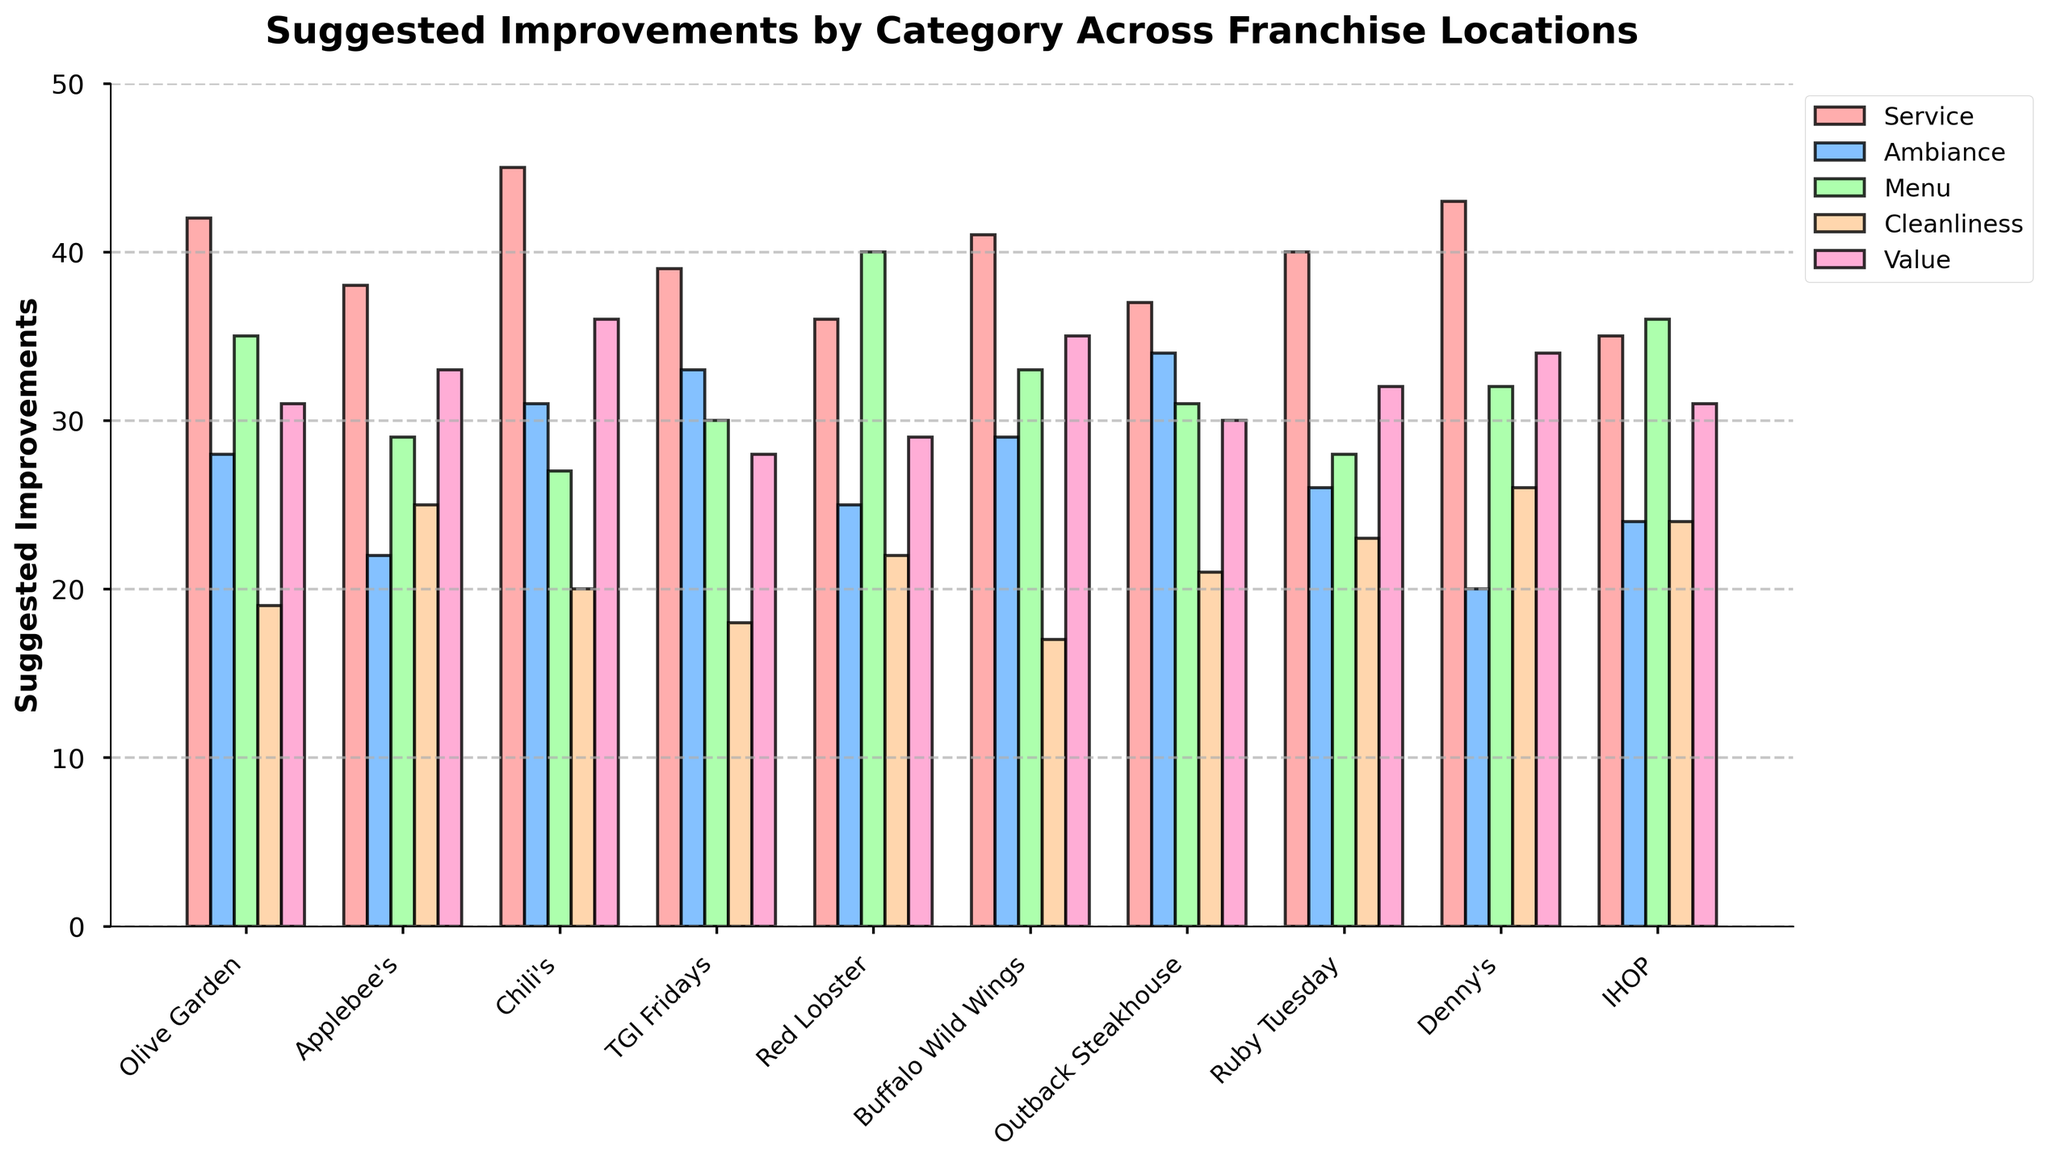What's the total number of suggested improvements for Service across all locations? Sum the suggested improvements for Service: 42 + 38 + 45 + 39 + 36 + 41 + 37 + 40 + 43 + 35 = 396.
Answer: 396 Which franchise location has the highest number of suggested improvements for Ambiance? Compare the values in the Ambiance column; the highest value is 34 for Outback Steakhouse.
Answer: Outback Steakhouse What's the average number of suggested improvements for Menu and Cleanliness across all franchise locations? Average for Menu: (35 + 29 + 27 + 30 + 40 + 33 + 31 + 28 + 32 + 36)/10 = 32.1; Average for Cleanliness: (19 + 25 + 20 + 18 + 22 + 17 + 21 + 23 + 26 + 24)/10 = 21.5. The combined average is (32.1 + 21.5)/2 = 26.8.
Answer: 26.8 Which category has the lowest suggested improvement for Denny's? Identify the lowest value in the row for Denny's: Service=43, Ambiance=20, Menu=32, Cleanliness=26, Value=34. The lowest is 20 for Ambiance.
Answer: Ambiance For which category does Olive Garden have the most suggested improvements? Identify the highest value in the row for Olive Garden: Service=42, Ambiance=28, Menu=35, Cleanliness=19, Value=31. The highest is 42 for Service.
Answer: Service How many more suggested improvements for Value did Chili's receive compared to Applebee's? Subtract the Value of Applebee's (33) from the Value of Chili's (36): 36 - 33 = 3.
Answer: 3 Which category has the highest variation of suggested improvements across all locations? Compare the range for each category: 
Service (43-35=8), 
Ambiance (34-20=14), 
Menu (40-27=13), 
Cleanliness (26-17=9), 
Value (36-28=8). 
Ambiance has the highest variation.
Answer: Ambiance What's the total suggested improvements for Service and Value combined at Chili's? Sum the values for Service and Value at Chili's: 45 (Service) + 36 (Value) = 81
Answer: 81 Which category received the most suggested improvements overall across all franchise locations? Sum the values for each category across all locations and compare:
Service=396, 
Ambiance=272, 
Menu=321, 
Cleanliness=215, 
Value=319. Service has the highest total.
Answer: Service 